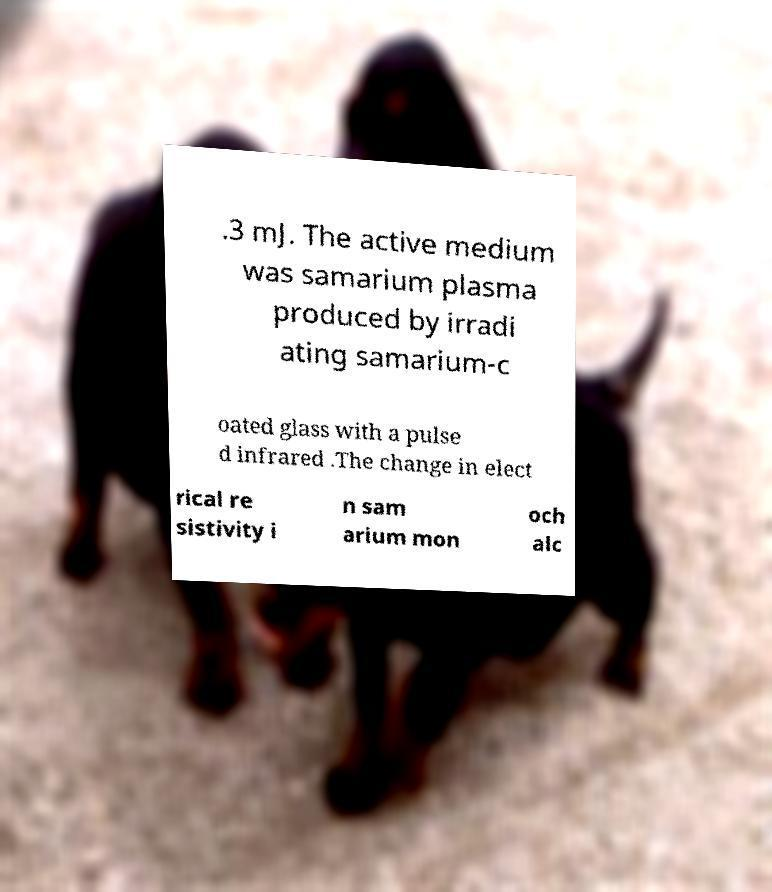There's text embedded in this image that I need extracted. Can you transcribe it verbatim? .3 mJ. The active medium was samarium plasma produced by irradi ating samarium-c oated glass with a pulse d infrared .The change in elect rical re sistivity i n sam arium mon och alc 